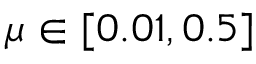<formula> <loc_0><loc_0><loc_500><loc_500>\mu \in [ 0 . 0 1 , 0 . 5 ]</formula> 